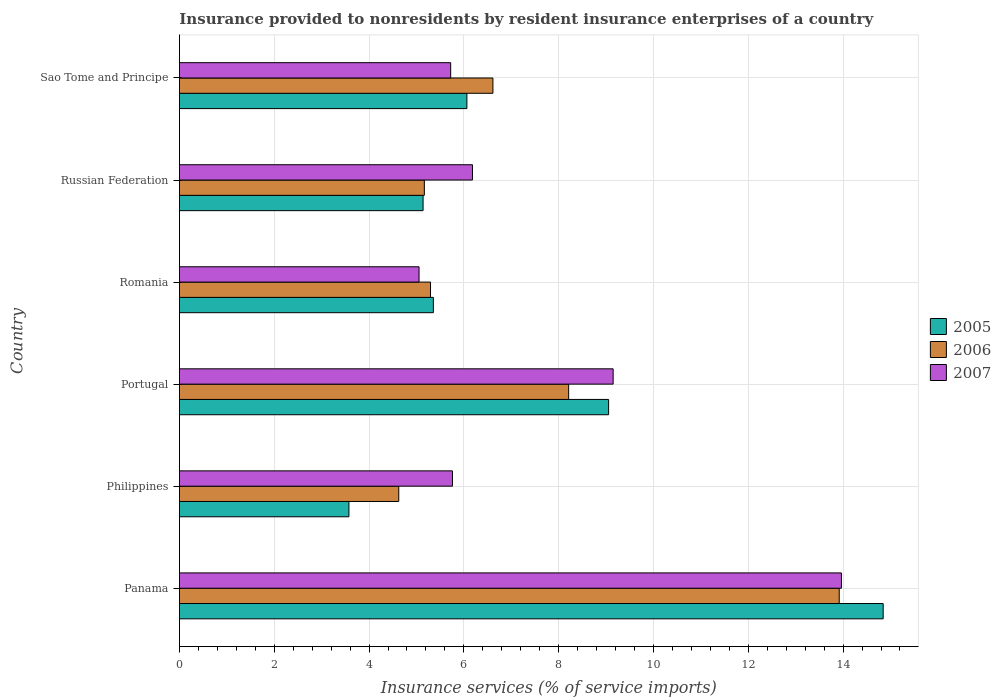How many groups of bars are there?
Your answer should be very brief. 6. How many bars are there on the 3rd tick from the top?
Your answer should be compact. 3. How many bars are there on the 4th tick from the bottom?
Your answer should be compact. 3. What is the insurance provided to nonresidents in 2005 in Philippines?
Your answer should be very brief. 3.58. Across all countries, what is the maximum insurance provided to nonresidents in 2007?
Provide a succinct answer. 13.97. Across all countries, what is the minimum insurance provided to nonresidents in 2007?
Offer a very short reply. 5.05. In which country was the insurance provided to nonresidents in 2007 maximum?
Your response must be concise. Panama. What is the total insurance provided to nonresidents in 2006 in the graph?
Provide a short and direct response. 43.83. What is the difference between the insurance provided to nonresidents in 2005 in Romania and that in Russian Federation?
Your answer should be very brief. 0.22. What is the difference between the insurance provided to nonresidents in 2007 in Russian Federation and the insurance provided to nonresidents in 2006 in Romania?
Give a very brief answer. 0.89. What is the average insurance provided to nonresidents in 2005 per country?
Your response must be concise. 7.34. What is the difference between the insurance provided to nonresidents in 2005 and insurance provided to nonresidents in 2006 in Philippines?
Your answer should be compact. -1.05. In how many countries, is the insurance provided to nonresidents in 2006 greater than 1.2000000000000002 %?
Provide a succinct answer. 6. What is the ratio of the insurance provided to nonresidents in 2006 in Romania to that in Russian Federation?
Your response must be concise. 1.03. Is the difference between the insurance provided to nonresidents in 2005 in Philippines and Romania greater than the difference between the insurance provided to nonresidents in 2006 in Philippines and Romania?
Provide a succinct answer. No. What is the difference between the highest and the second highest insurance provided to nonresidents in 2006?
Keep it short and to the point. 5.71. What is the difference between the highest and the lowest insurance provided to nonresidents in 2006?
Offer a very short reply. 9.29. Is the sum of the insurance provided to nonresidents in 2005 in Philippines and Portugal greater than the maximum insurance provided to nonresidents in 2006 across all countries?
Give a very brief answer. No. What does the 2nd bar from the bottom in Philippines represents?
Keep it short and to the point. 2006. Is it the case that in every country, the sum of the insurance provided to nonresidents in 2007 and insurance provided to nonresidents in 2005 is greater than the insurance provided to nonresidents in 2006?
Ensure brevity in your answer.  Yes. How many bars are there?
Provide a short and direct response. 18. Are all the bars in the graph horizontal?
Provide a succinct answer. Yes. How many countries are there in the graph?
Make the answer very short. 6. Are the values on the major ticks of X-axis written in scientific E-notation?
Your answer should be very brief. No. Does the graph contain any zero values?
Your answer should be very brief. No. Does the graph contain grids?
Your response must be concise. Yes. Where does the legend appear in the graph?
Provide a short and direct response. Center right. How many legend labels are there?
Your answer should be very brief. 3. What is the title of the graph?
Give a very brief answer. Insurance provided to nonresidents by resident insurance enterprises of a country. What is the label or title of the X-axis?
Offer a very short reply. Insurance services (% of service imports). What is the Insurance services (% of service imports) in 2005 in Panama?
Offer a terse response. 14.85. What is the Insurance services (% of service imports) in 2006 in Panama?
Offer a terse response. 13.92. What is the Insurance services (% of service imports) of 2007 in Panama?
Ensure brevity in your answer.  13.97. What is the Insurance services (% of service imports) in 2005 in Philippines?
Provide a short and direct response. 3.58. What is the Insurance services (% of service imports) in 2006 in Philippines?
Offer a terse response. 4.63. What is the Insurance services (% of service imports) in 2007 in Philippines?
Your answer should be very brief. 5.76. What is the Insurance services (% of service imports) of 2005 in Portugal?
Your answer should be compact. 9.05. What is the Insurance services (% of service imports) of 2006 in Portugal?
Provide a short and direct response. 8.21. What is the Insurance services (% of service imports) of 2007 in Portugal?
Your answer should be very brief. 9.15. What is the Insurance services (% of service imports) in 2005 in Romania?
Make the answer very short. 5.36. What is the Insurance services (% of service imports) of 2006 in Romania?
Your answer should be very brief. 5.3. What is the Insurance services (% of service imports) in 2007 in Romania?
Offer a terse response. 5.05. What is the Insurance services (% of service imports) of 2005 in Russian Federation?
Your response must be concise. 5.14. What is the Insurance services (% of service imports) in 2006 in Russian Federation?
Your answer should be very brief. 5.17. What is the Insurance services (% of service imports) of 2007 in Russian Federation?
Your response must be concise. 6.18. What is the Insurance services (% of service imports) of 2005 in Sao Tome and Principe?
Keep it short and to the point. 6.06. What is the Insurance services (% of service imports) in 2006 in Sao Tome and Principe?
Offer a terse response. 6.61. What is the Insurance services (% of service imports) in 2007 in Sao Tome and Principe?
Your answer should be compact. 5.72. Across all countries, what is the maximum Insurance services (% of service imports) in 2005?
Provide a succinct answer. 14.85. Across all countries, what is the maximum Insurance services (% of service imports) of 2006?
Ensure brevity in your answer.  13.92. Across all countries, what is the maximum Insurance services (% of service imports) of 2007?
Provide a succinct answer. 13.97. Across all countries, what is the minimum Insurance services (% of service imports) in 2005?
Offer a very short reply. 3.58. Across all countries, what is the minimum Insurance services (% of service imports) of 2006?
Your answer should be compact. 4.63. Across all countries, what is the minimum Insurance services (% of service imports) of 2007?
Provide a succinct answer. 5.05. What is the total Insurance services (% of service imports) of 2005 in the graph?
Offer a terse response. 44.04. What is the total Insurance services (% of service imports) in 2006 in the graph?
Ensure brevity in your answer.  43.83. What is the total Insurance services (% of service imports) in 2007 in the graph?
Give a very brief answer. 45.83. What is the difference between the Insurance services (% of service imports) of 2005 in Panama and that in Philippines?
Your answer should be compact. 11.27. What is the difference between the Insurance services (% of service imports) in 2006 in Panama and that in Philippines?
Make the answer very short. 9.29. What is the difference between the Insurance services (% of service imports) in 2007 in Panama and that in Philippines?
Offer a terse response. 8.21. What is the difference between the Insurance services (% of service imports) in 2005 in Panama and that in Portugal?
Offer a terse response. 5.79. What is the difference between the Insurance services (% of service imports) in 2006 in Panama and that in Portugal?
Keep it short and to the point. 5.71. What is the difference between the Insurance services (% of service imports) of 2007 in Panama and that in Portugal?
Your response must be concise. 4.82. What is the difference between the Insurance services (% of service imports) of 2005 in Panama and that in Romania?
Provide a succinct answer. 9.49. What is the difference between the Insurance services (% of service imports) of 2006 in Panama and that in Romania?
Offer a terse response. 8.62. What is the difference between the Insurance services (% of service imports) in 2007 in Panama and that in Romania?
Give a very brief answer. 8.91. What is the difference between the Insurance services (% of service imports) of 2005 in Panama and that in Russian Federation?
Give a very brief answer. 9.71. What is the difference between the Insurance services (% of service imports) in 2006 in Panama and that in Russian Federation?
Ensure brevity in your answer.  8.75. What is the difference between the Insurance services (% of service imports) in 2007 in Panama and that in Russian Federation?
Your response must be concise. 7.78. What is the difference between the Insurance services (% of service imports) of 2005 in Panama and that in Sao Tome and Principe?
Your answer should be compact. 8.78. What is the difference between the Insurance services (% of service imports) in 2006 in Panama and that in Sao Tome and Principe?
Your response must be concise. 7.31. What is the difference between the Insurance services (% of service imports) of 2007 in Panama and that in Sao Tome and Principe?
Provide a succinct answer. 8.24. What is the difference between the Insurance services (% of service imports) of 2005 in Philippines and that in Portugal?
Offer a very short reply. -5.48. What is the difference between the Insurance services (% of service imports) of 2006 in Philippines and that in Portugal?
Provide a succinct answer. -3.58. What is the difference between the Insurance services (% of service imports) of 2007 in Philippines and that in Portugal?
Your response must be concise. -3.39. What is the difference between the Insurance services (% of service imports) in 2005 in Philippines and that in Romania?
Your response must be concise. -1.78. What is the difference between the Insurance services (% of service imports) of 2006 in Philippines and that in Romania?
Your answer should be compact. -0.67. What is the difference between the Insurance services (% of service imports) in 2007 in Philippines and that in Romania?
Ensure brevity in your answer.  0.7. What is the difference between the Insurance services (% of service imports) in 2005 in Philippines and that in Russian Federation?
Make the answer very short. -1.56. What is the difference between the Insurance services (% of service imports) in 2006 in Philippines and that in Russian Federation?
Offer a very short reply. -0.54. What is the difference between the Insurance services (% of service imports) of 2007 in Philippines and that in Russian Federation?
Ensure brevity in your answer.  -0.42. What is the difference between the Insurance services (% of service imports) of 2005 in Philippines and that in Sao Tome and Principe?
Your answer should be very brief. -2.49. What is the difference between the Insurance services (% of service imports) of 2006 in Philippines and that in Sao Tome and Principe?
Make the answer very short. -1.99. What is the difference between the Insurance services (% of service imports) of 2007 in Philippines and that in Sao Tome and Principe?
Your answer should be compact. 0.04. What is the difference between the Insurance services (% of service imports) in 2005 in Portugal and that in Romania?
Provide a short and direct response. 3.7. What is the difference between the Insurance services (% of service imports) in 2006 in Portugal and that in Romania?
Keep it short and to the point. 2.91. What is the difference between the Insurance services (% of service imports) in 2007 in Portugal and that in Romania?
Give a very brief answer. 4.09. What is the difference between the Insurance services (% of service imports) of 2005 in Portugal and that in Russian Federation?
Your answer should be very brief. 3.91. What is the difference between the Insurance services (% of service imports) of 2006 in Portugal and that in Russian Federation?
Your answer should be compact. 3.04. What is the difference between the Insurance services (% of service imports) of 2007 in Portugal and that in Russian Federation?
Offer a very short reply. 2.97. What is the difference between the Insurance services (% of service imports) of 2005 in Portugal and that in Sao Tome and Principe?
Give a very brief answer. 2.99. What is the difference between the Insurance services (% of service imports) of 2006 in Portugal and that in Sao Tome and Principe?
Your answer should be compact. 1.6. What is the difference between the Insurance services (% of service imports) in 2007 in Portugal and that in Sao Tome and Principe?
Keep it short and to the point. 3.43. What is the difference between the Insurance services (% of service imports) of 2005 in Romania and that in Russian Federation?
Make the answer very short. 0.22. What is the difference between the Insurance services (% of service imports) in 2006 in Romania and that in Russian Federation?
Make the answer very short. 0.13. What is the difference between the Insurance services (% of service imports) in 2007 in Romania and that in Russian Federation?
Your response must be concise. -1.13. What is the difference between the Insurance services (% of service imports) of 2005 in Romania and that in Sao Tome and Principe?
Offer a very short reply. -0.71. What is the difference between the Insurance services (% of service imports) of 2006 in Romania and that in Sao Tome and Principe?
Make the answer very short. -1.32. What is the difference between the Insurance services (% of service imports) of 2007 in Romania and that in Sao Tome and Principe?
Make the answer very short. -0.67. What is the difference between the Insurance services (% of service imports) in 2005 in Russian Federation and that in Sao Tome and Principe?
Give a very brief answer. -0.92. What is the difference between the Insurance services (% of service imports) of 2006 in Russian Federation and that in Sao Tome and Principe?
Give a very brief answer. -1.45. What is the difference between the Insurance services (% of service imports) of 2007 in Russian Federation and that in Sao Tome and Principe?
Provide a short and direct response. 0.46. What is the difference between the Insurance services (% of service imports) in 2005 in Panama and the Insurance services (% of service imports) in 2006 in Philippines?
Ensure brevity in your answer.  10.22. What is the difference between the Insurance services (% of service imports) of 2005 in Panama and the Insurance services (% of service imports) of 2007 in Philippines?
Your answer should be very brief. 9.09. What is the difference between the Insurance services (% of service imports) in 2006 in Panama and the Insurance services (% of service imports) in 2007 in Philippines?
Provide a succinct answer. 8.16. What is the difference between the Insurance services (% of service imports) in 2005 in Panama and the Insurance services (% of service imports) in 2006 in Portugal?
Ensure brevity in your answer.  6.63. What is the difference between the Insurance services (% of service imports) of 2005 in Panama and the Insurance services (% of service imports) of 2007 in Portugal?
Ensure brevity in your answer.  5.7. What is the difference between the Insurance services (% of service imports) of 2006 in Panama and the Insurance services (% of service imports) of 2007 in Portugal?
Provide a succinct answer. 4.77. What is the difference between the Insurance services (% of service imports) in 2005 in Panama and the Insurance services (% of service imports) in 2006 in Romania?
Offer a terse response. 9.55. What is the difference between the Insurance services (% of service imports) of 2005 in Panama and the Insurance services (% of service imports) of 2007 in Romania?
Make the answer very short. 9.79. What is the difference between the Insurance services (% of service imports) in 2006 in Panama and the Insurance services (% of service imports) in 2007 in Romania?
Keep it short and to the point. 8.86. What is the difference between the Insurance services (% of service imports) of 2005 in Panama and the Insurance services (% of service imports) of 2006 in Russian Federation?
Ensure brevity in your answer.  9.68. What is the difference between the Insurance services (% of service imports) in 2005 in Panama and the Insurance services (% of service imports) in 2007 in Russian Federation?
Your answer should be very brief. 8.66. What is the difference between the Insurance services (% of service imports) of 2006 in Panama and the Insurance services (% of service imports) of 2007 in Russian Federation?
Keep it short and to the point. 7.74. What is the difference between the Insurance services (% of service imports) of 2005 in Panama and the Insurance services (% of service imports) of 2006 in Sao Tome and Principe?
Give a very brief answer. 8.23. What is the difference between the Insurance services (% of service imports) of 2005 in Panama and the Insurance services (% of service imports) of 2007 in Sao Tome and Principe?
Make the answer very short. 9.12. What is the difference between the Insurance services (% of service imports) in 2006 in Panama and the Insurance services (% of service imports) in 2007 in Sao Tome and Principe?
Ensure brevity in your answer.  8.2. What is the difference between the Insurance services (% of service imports) in 2005 in Philippines and the Insurance services (% of service imports) in 2006 in Portugal?
Offer a very short reply. -4.64. What is the difference between the Insurance services (% of service imports) of 2005 in Philippines and the Insurance services (% of service imports) of 2007 in Portugal?
Keep it short and to the point. -5.57. What is the difference between the Insurance services (% of service imports) of 2006 in Philippines and the Insurance services (% of service imports) of 2007 in Portugal?
Ensure brevity in your answer.  -4.52. What is the difference between the Insurance services (% of service imports) in 2005 in Philippines and the Insurance services (% of service imports) in 2006 in Romania?
Give a very brief answer. -1.72. What is the difference between the Insurance services (% of service imports) of 2005 in Philippines and the Insurance services (% of service imports) of 2007 in Romania?
Provide a short and direct response. -1.48. What is the difference between the Insurance services (% of service imports) of 2006 in Philippines and the Insurance services (% of service imports) of 2007 in Romania?
Your answer should be very brief. -0.43. What is the difference between the Insurance services (% of service imports) of 2005 in Philippines and the Insurance services (% of service imports) of 2006 in Russian Federation?
Provide a short and direct response. -1.59. What is the difference between the Insurance services (% of service imports) in 2005 in Philippines and the Insurance services (% of service imports) in 2007 in Russian Federation?
Make the answer very short. -2.61. What is the difference between the Insurance services (% of service imports) in 2006 in Philippines and the Insurance services (% of service imports) in 2007 in Russian Federation?
Make the answer very short. -1.55. What is the difference between the Insurance services (% of service imports) in 2005 in Philippines and the Insurance services (% of service imports) in 2006 in Sao Tome and Principe?
Your response must be concise. -3.04. What is the difference between the Insurance services (% of service imports) in 2005 in Philippines and the Insurance services (% of service imports) in 2007 in Sao Tome and Principe?
Ensure brevity in your answer.  -2.15. What is the difference between the Insurance services (% of service imports) in 2006 in Philippines and the Insurance services (% of service imports) in 2007 in Sao Tome and Principe?
Offer a terse response. -1.09. What is the difference between the Insurance services (% of service imports) of 2005 in Portugal and the Insurance services (% of service imports) of 2006 in Romania?
Offer a terse response. 3.76. What is the difference between the Insurance services (% of service imports) of 2005 in Portugal and the Insurance services (% of service imports) of 2007 in Romania?
Your answer should be very brief. 4. What is the difference between the Insurance services (% of service imports) in 2006 in Portugal and the Insurance services (% of service imports) in 2007 in Romania?
Make the answer very short. 3.16. What is the difference between the Insurance services (% of service imports) of 2005 in Portugal and the Insurance services (% of service imports) of 2006 in Russian Federation?
Your answer should be compact. 3.89. What is the difference between the Insurance services (% of service imports) of 2005 in Portugal and the Insurance services (% of service imports) of 2007 in Russian Federation?
Give a very brief answer. 2.87. What is the difference between the Insurance services (% of service imports) in 2006 in Portugal and the Insurance services (% of service imports) in 2007 in Russian Federation?
Your answer should be very brief. 2.03. What is the difference between the Insurance services (% of service imports) in 2005 in Portugal and the Insurance services (% of service imports) in 2006 in Sao Tome and Principe?
Provide a succinct answer. 2.44. What is the difference between the Insurance services (% of service imports) of 2005 in Portugal and the Insurance services (% of service imports) of 2007 in Sao Tome and Principe?
Offer a very short reply. 3.33. What is the difference between the Insurance services (% of service imports) of 2006 in Portugal and the Insurance services (% of service imports) of 2007 in Sao Tome and Principe?
Make the answer very short. 2.49. What is the difference between the Insurance services (% of service imports) in 2005 in Romania and the Insurance services (% of service imports) in 2006 in Russian Federation?
Give a very brief answer. 0.19. What is the difference between the Insurance services (% of service imports) in 2005 in Romania and the Insurance services (% of service imports) in 2007 in Russian Federation?
Your answer should be very brief. -0.82. What is the difference between the Insurance services (% of service imports) in 2006 in Romania and the Insurance services (% of service imports) in 2007 in Russian Federation?
Provide a short and direct response. -0.89. What is the difference between the Insurance services (% of service imports) in 2005 in Romania and the Insurance services (% of service imports) in 2006 in Sao Tome and Principe?
Your answer should be compact. -1.26. What is the difference between the Insurance services (% of service imports) in 2005 in Romania and the Insurance services (% of service imports) in 2007 in Sao Tome and Principe?
Offer a very short reply. -0.36. What is the difference between the Insurance services (% of service imports) of 2006 in Romania and the Insurance services (% of service imports) of 2007 in Sao Tome and Principe?
Offer a very short reply. -0.43. What is the difference between the Insurance services (% of service imports) of 2005 in Russian Federation and the Insurance services (% of service imports) of 2006 in Sao Tome and Principe?
Your response must be concise. -1.47. What is the difference between the Insurance services (% of service imports) of 2005 in Russian Federation and the Insurance services (% of service imports) of 2007 in Sao Tome and Principe?
Keep it short and to the point. -0.58. What is the difference between the Insurance services (% of service imports) in 2006 in Russian Federation and the Insurance services (% of service imports) in 2007 in Sao Tome and Principe?
Ensure brevity in your answer.  -0.56. What is the average Insurance services (% of service imports) of 2005 per country?
Give a very brief answer. 7.34. What is the average Insurance services (% of service imports) in 2006 per country?
Give a very brief answer. 7.31. What is the average Insurance services (% of service imports) of 2007 per country?
Make the answer very short. 7.64. What is the difference between the Insurance services (% of service imports) in 2005 and Insurance services (% of service imports) in 2006 in Panama?
Your answer should be very brief. 0.93. What is the difference between the Insurance services (% of service imports) of 2005 and Insurance services (% of service imports) of 2007 in Panama?
Your response must be concise. 0.88. What is the difference between the Insurance services (% of service imports) in 2006 and Insurance services (% of service imports) in 2007 in Panama?
Keep it short and to the point. -0.05. What is the difference between the Insurance services (% of service imports) in 2005 and Insurance services (% of service imports) in 2006 in Philippines?
Your answer should be very brief. -1.05. What is the difference between the Insurance services (% of service imports) in 2005 and Insurance services (% of service imports) in 2007 in Philippines?
Your answer should be very brief. -2.18. What is the difference between the Insurance services (% of service imports) in 2006 and Insurance services (% of service imports) in 2007 in Philippines?
Offer a terse response. -1.13. What is the difference between the Insurance services (% of service imports) of 2005 and Insurance services (% of service imports) of 2006 in Portugal?
Ensure brevity in your answer.  0.84. What is the difference between the Insurance services (% of service imports) in 2005 and Insurance services (% of service imports) in 2007 in Portugal?
Give a very brief answer. -0.1. What is the difference between the Insurance services (% of service imports) of 2006 and Insurance services (% of service imports) of 2007 in Portugal?
Offer a terse response. -0.94. What is the difference between the Insurance services (% of service imports) of 2005 and Insurance services (% of service imports) of 2006 in Romania?
Ensure brevity in your answer.  0.06. What is the difference between the Insurance services (% of service imports) of 2005 and Insurance services (% of service imports) of 2007 in Romania?
Offer a very short reply. 0.3. What is the difference between the Insurance services (% of service imports) in 2006 and Insurance services (% of service imports) in 2007 in Romania?
Provide a short and direct response. 0.24. What is the difference between the Insurance services (% of service imports) in 2005 and Insurance services (% of service imports) in 2006 in Russian Federation?
Your response must be concise. -0.03. What is the difference between the Insurance services (% of service imports) of 2005 and Insurance services (% of service imports) of 2007 in Russian Federation?
Give a very brief answer. -1.04. What is the difference between the Insurance services (% of service imports) of 2006 and Insurance services (% of service imports) of 2007 in Russian Federation?
Ensure brevity in your answer.  -1.02. What is the difference between the Insurance services (% of service imports) of 2005 and Insurance services (% of service imports) of 2006 in Sao Tome and Principe?
Provide a short and direct response. -0.55. What is the difference between the Insurance services (% of service imports) in 2005 and Insurance services (% of service imports) in 2007 in Sao Tome and Principe?
Your response must be concise. 0.34. What is the difference between the Insurance services (% of service imports) of 2006 and Insurance services (% of service imports) of 2007 in Sao Tome and Principe?
Ensure brevity in your answer.  0.89. What is the ratio of the Insurance services (% of service imports) in 2005 in Panama to that in Philippines?
Your response must be concise. 4.15. What is the ratio of the Insurance services (% of service imports) of 2006 in Panama to that in Philippines?
Ensure brevity in your answer.  3.01. What is the ratio of the Insurance services (% of service imports) of 2007 in Panama to that in Philippines?
Provide a succinct answer. 2.42. What is the ratio of the Insurance services (% of service imports) in 2005 in Panama to that in Portugal?
Keep it short and to the point. 1.64. What is the ratio of the Insurance services (% of service imports) of 2006 in Panama to that in Portugal?
Provide a succinct answer. 1.7. What is the ratio of the Insurance services (% of service imports) of 2007 in Panama to that in Portugal?
Your answer should be very brief. 1.53. What is the ratio of the Insurance services (% of service imports) in 2005 in Panama to that in Romania?
Ensure brevity in your answer.  2.77. What is the ratio of the Insurance services (% of service imports) of 2006 in Panama to that in Romania?
Your answer should be compact. 2.63. What is the ratio of the Insurance services (% of service imports) of 2007 in Panama to that in Romania?
Make the answer very short. 2.76. What is the ratio of the Insurance services (% of service imports) in 2005 in Panama to that in Russian Federation?
Offer a terse response. 2.89. What is the ratio of the Insurance services (% of service imports) in 2006 in Panama to that in Russian Federation?
Provide a short and direct response. 2.69. What is the ratio of the Insurance services (% of service imports) in 2007 in Panama to that in Russian Federation?
Your answer should be compact. 2.26. What is the ratio of the Insurance services (% of service imports) of 2005 in Panama to that in Sao Tome and Principe?
Offer a very short reply. 2.45. What is the ratio of the Insurance services (% of service imports) in 2006 in Panama to that in Sao Tome and Principe?
Offer a terse response. 2.1. What is the ratio of the Insurance services (% of service imports) in 2007 in Panama to that in Sao Tome and Principe?
Provide a short and direct response. 2.44. What is the ratio of the Insurance services (% of service imports) in 2005 in Philippines to that in Portugal?
Your answer should be very brief. 0.39. What is the ratio of the Insurance services (% of service imports) in 2006 in Philippines to that in Portugal?
Give a very brief answer. 0.56. What is the ratio of the Insurance services (% of service imports) of 2007 in Philippines to that in Portugal?
Give a very brief answer. 0.63. What is the ratio of the Insurance services (% of service imports) of 2005 in Philippines to that in Romania?
Your answer should be very brief. 0.67. What is the ratio of the Insurance services (% of service imports) in 2006 in Philippines to that in Romania?
Give a very brief answer. 0.87. What is the ratio of the Insurance services (% of service imports) of 2007 in Philippines to that in Romania?
Ensure brevity in your answer.  1.14. What is the ratio of the Insurance services (% of service imports) of 2005 in Philippines to that in Russian Federation?
Your response must be concise. 0.7. What is the ratio of the Insurance services (% of service imports) of 2006 in Philippines to that in Russian Federation?
Your answer should be very brief. 0.9. What is the ratio of the Insurance services (% of service imports) in 2007 in Philippines to that in Russian Federation?
Give a very brief answer. 0.93. What is the ratio of the Insurance services (% of service imports) in 2005 in Philippines to that in Sao Tome and Principe?
Provide a short and direct response. 0.59. What is the ratio of the Insurance services (% of service imports) in 2006 in Philippines to that in Sao Tome and Principe?
Provide a short and direct response. 0.7. What is the ratio of the Insurance services (% of service imports) of 2007 in Philippines to that in Sao Tome and Principe?
Provide a short and direct response. 1.01. What is the ratio of the Insurance services (% of service imports) in 2005 in Portugal to that in Romania?
Make the answer very short. 1.69. What is the ratio of the Insurance services (% of service imports) in 2006 in Portugal to that in Romania?
Offer a very short reply. 1.55. What is the ratio of the Insurance services (% of service imports) of 2007 in Portugal to that in Romania?
Your answer should be compact. 1.81. What is the ratio of the Insurance services (% of service imports) in 2005 in Portugal to that in Russian Federation?
Your answer should be very brief. 1.76. What is the ratio of the Insurance services (% of service imports) in 2006 in Portugal to that in Russian Federation?
Give a very brief answer. 1.59. What is the ratio of the Insurance services (% of service imports) of 2007 in Portugal to that in Russian Federation?
Provide a succinct answer. 1.48. What is the ratio of the Insurance services (% of service imports) in 2005 in Portugal to that in Sao Tome and Principe?
Provide a short and direct response. 1.49. What is the ratio of the Insurance services (% of service imports) of 2006 in Portugal to that in Sao Tome and Principe?
Provide a succinct answer. 1.24. What is the ratio of the Insurance services (% of service imports) in 2007 in Portugal to that in Sao Tome and Principe?
Offer a very short reply. 1.6. What is the ratio of the Insurance services (% of service imports) in 2005 in Romania to that in Russian Federation?
Keep it short and to the point. 1.04. What is the ratio of the Insurance services (% of service imports) of 2006 in Romania to that in Russian Federation?
Provide a succinct answer. 1.03. What is the ratio of the Insurance services (% of service imports) of 2007 in Romania to that in Russian Federation?
Your answer should be very brief. 0.82. What is the ratio of the Insurance services (% of service imports) in 2005 in Romania to that in Sao Tome and Principe?
Make the answer very short. 0.88. What is the ratio of the Insurance services (% of service imports) in 2006 in Romania to that in Sao Tome and Principe?
Provide a succinct answer. 0.8. What is the ratio of the Insurance services (% of service imports) of 2007 in Romania to that in Sao Tome and Principe?
Make the answer very short. 0.88. What is the ratio of the Insurance services (% of service imports) in 2005 in Russian Federation to that in Sao Tome and Principe?
Offer a terse response. 0.85. What is the ratio of the Insurance services (% of service imports) of 2006 in Russian Federation to that in Sao Tome and Principe?
Your response must be concise. 0.78. What is the ratio of the Insurance services (% of service imports) in 2007 in Russian Federation to that in Sao Tome and Principe?
Make the answer very short. 1.08. What is the difference between the highest and the second highest Insurance services (% of service imports) of 2005?
Your answer should be very brief. 5.79. What is the difference between the highest and the second highest Insurance services (% of service imports) in 2006?
Your answer should be compact. 5.71. What is the difference between the highest and the second highest Insurance services (% of service imports) of 2007?
Your answer should be compact. 4.82. What is the difference between the highest and the lowest Insurance services (% of service imports) in 2005?
Provide a short and direct response. 11.27. What is the difference between the highest and the lowest Insurance services (% of service imports) of 2006?
Your answer should be very brief. 9.29. What is the difference between the highest and the lowest Insurance services (% of service imports) of 2007?
Your answer should be very brief. 8.91. 